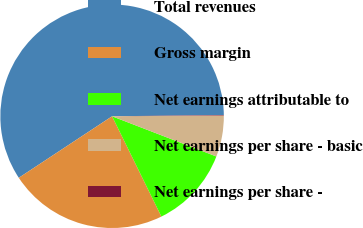<chart> <loc_0><loc_0><loc_500><loc_500><pie_chart><fcel>Total revenues<fcel>Gross margin<fcel>Net earnings attributable to<fcel>Net earnings per share - basic<fcel>Net earnings per share -<nl><fcel>59.09%<fcel>22.99%<fcel>11.87%<fcel>5.97%<fcel>0.07%<nl></chart> 